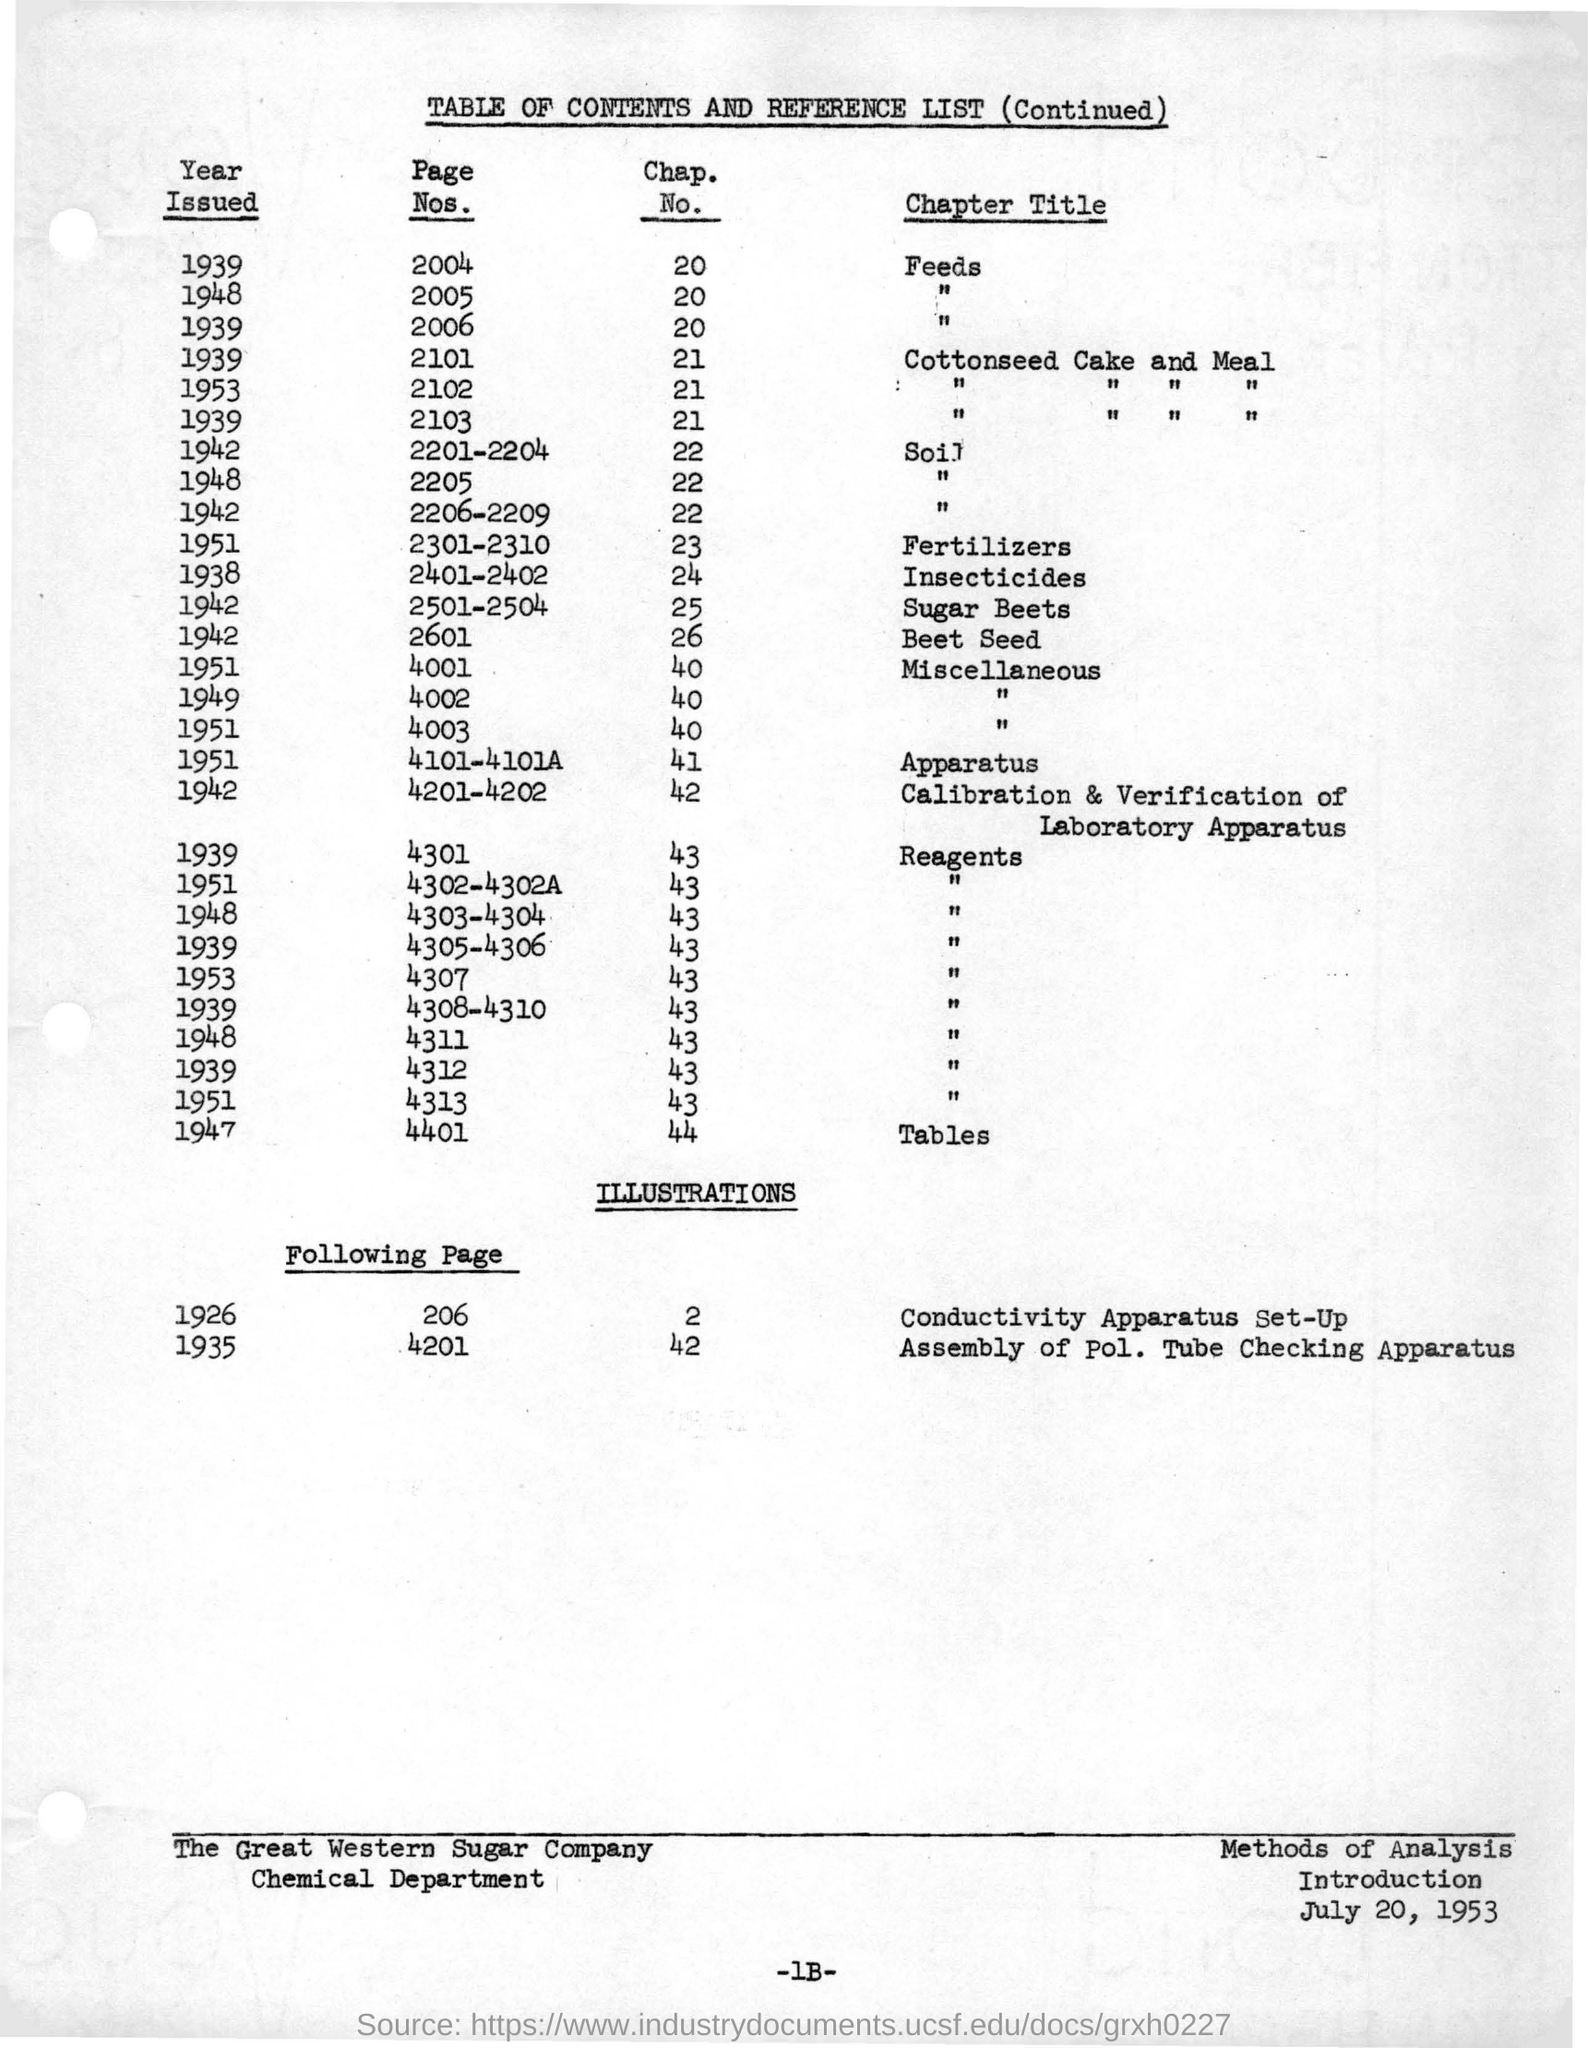What is the heading of the table?
Keep it short and to the point. TABLE OF CONTENTS AND REFERENCE LIST (Continued). In which year was Feeds issued?
Your answer should be compact. 1939. 